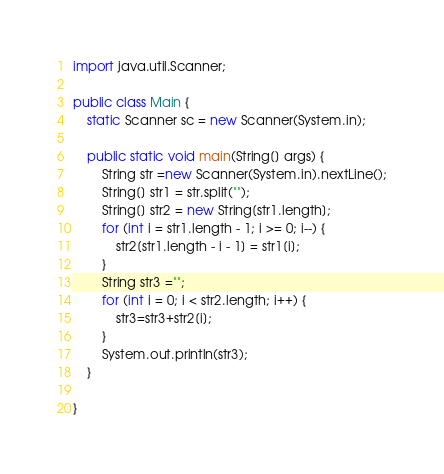Convert code to text. <code><loc_0><loc_0><loc_500><loc_500><_Java_>import java.util.Scanner;

public class Main {
	static Scanner sc = new Scanner(System.in);

	public static void main(String[] args) {
		String str =new Scanner(System.in).nextLine();
		String[] str1 = str.split("");
		String[] str2 = new String[str1.length];
		for (int i = str1.length - 1; i >= 0; i--) {
			str2[str1.length - i - 1] = str1[i];
		}
		String str3 ="";
		for (int i = 0; i < str2.length; i++) {
			str3=str3+str2[i];
		}
		System.out.println(str3);
	}

}</code> 